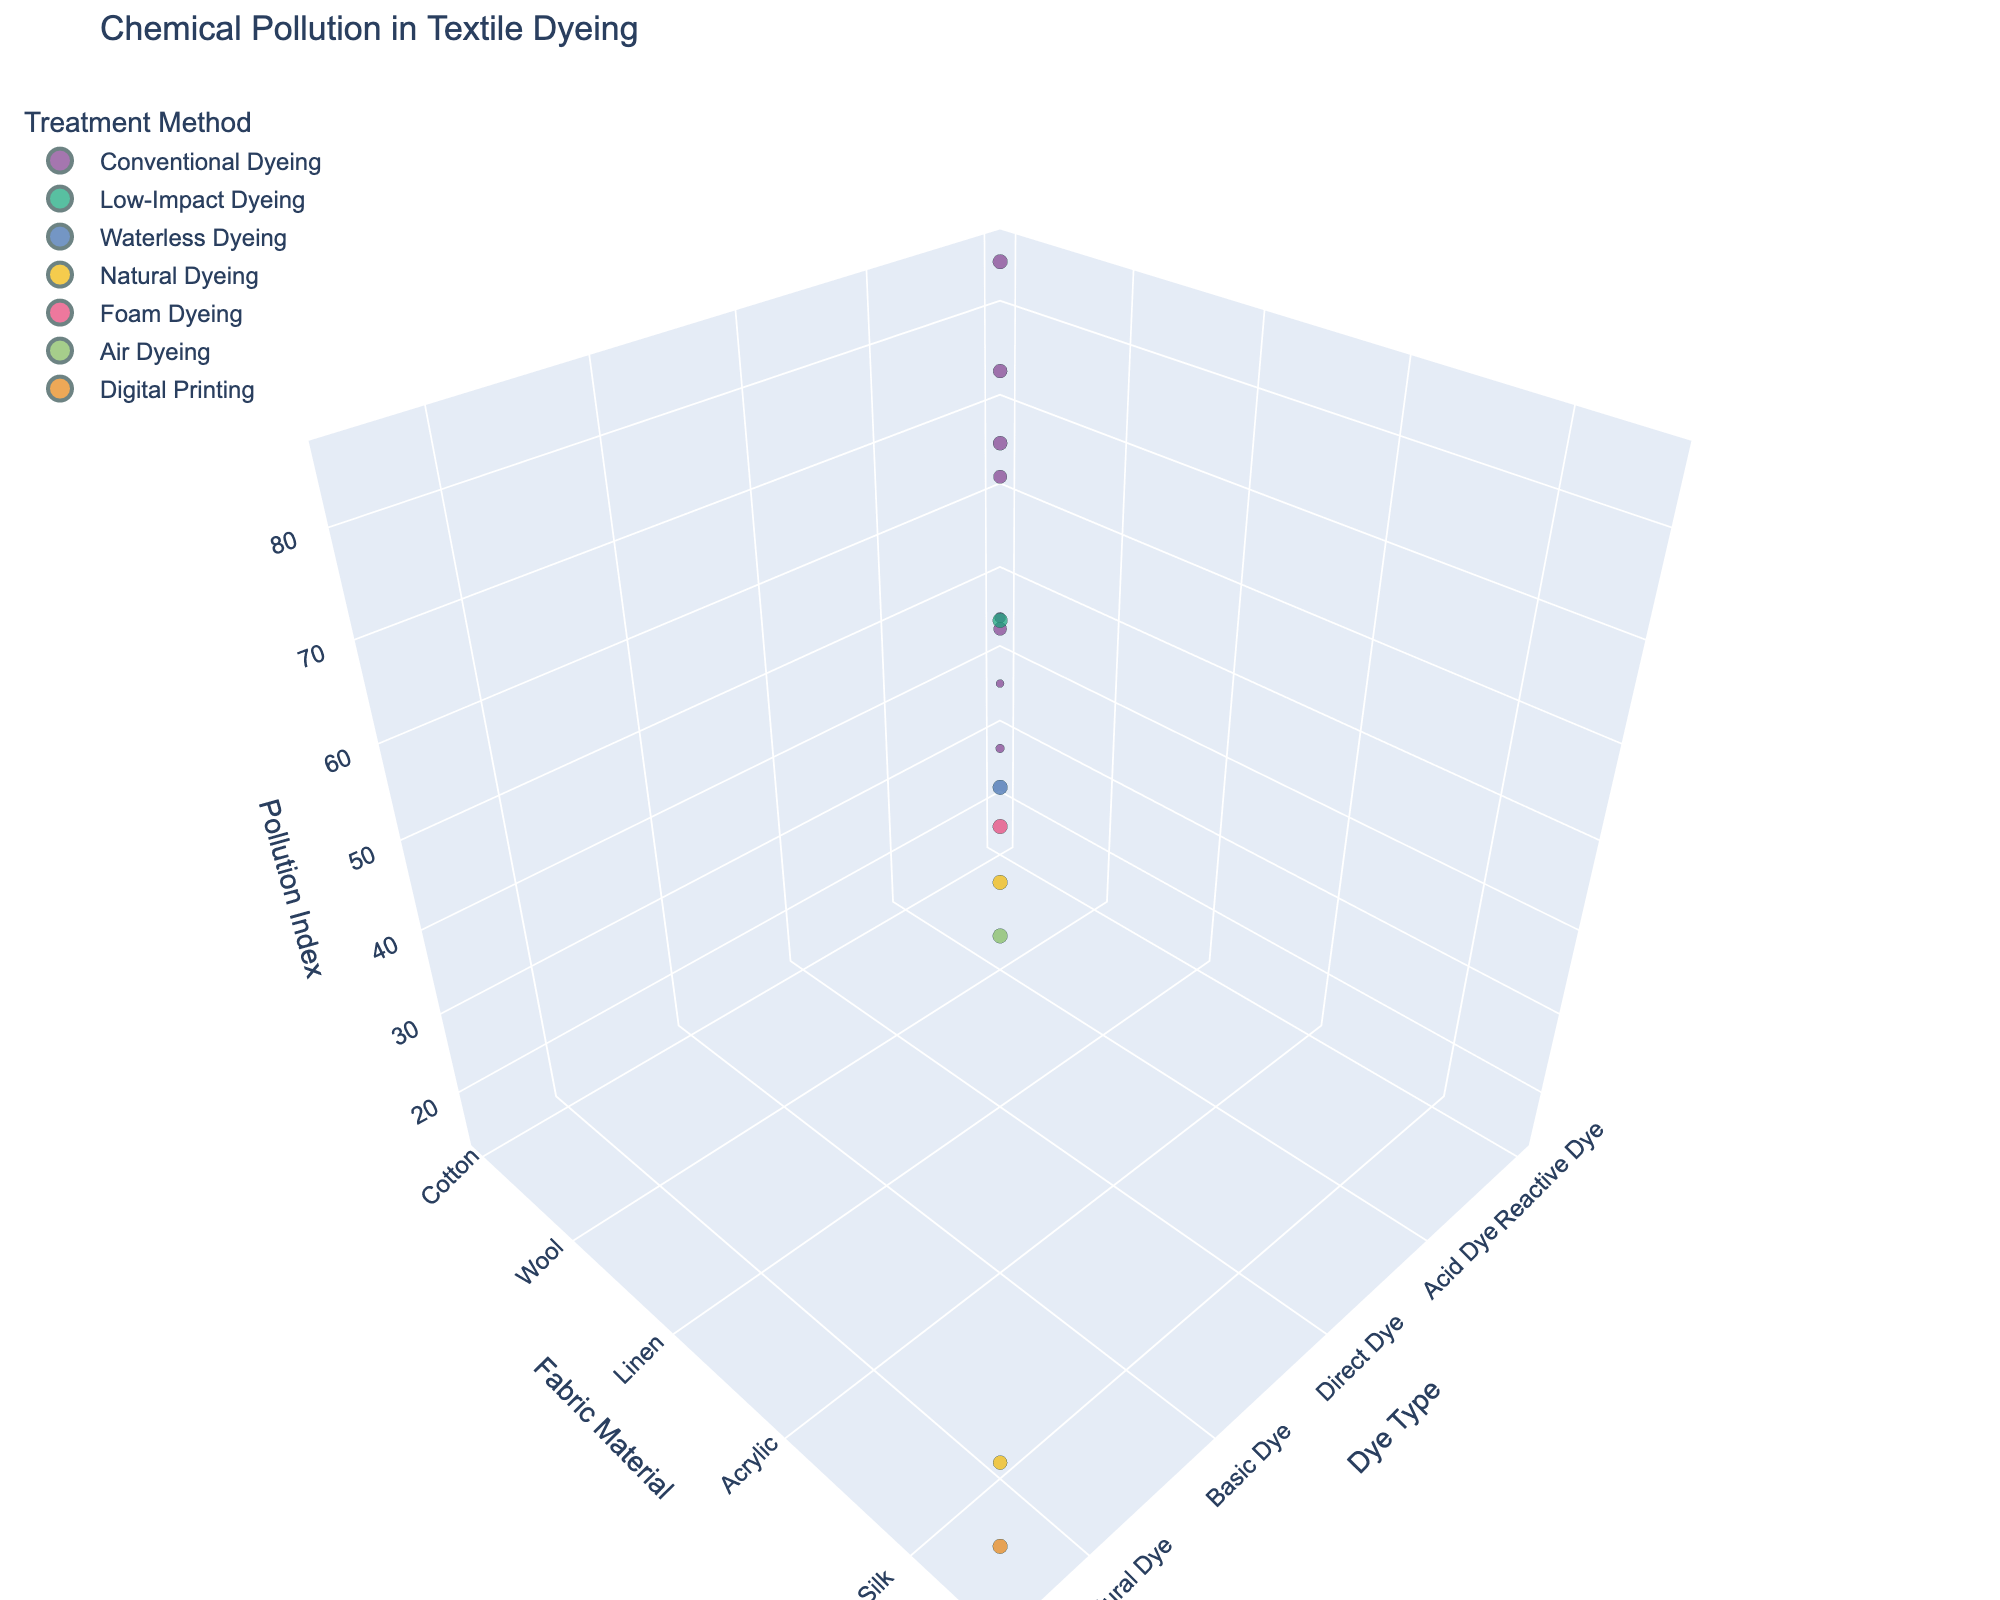What's the title of the 3D plot? The title of the plot is usually visible at the top of the figure.
Answer: Chemical Pollution in Textile Dyeing How many data points represent Conventional Dyeing? Count the number of data points that are colored the same and labeled as "Conventional Dyeing".
Answer: 7 Which dye type has the lowest chemical pollution index and what is the treatment method used? Look for the data point with the smallest z-value and note its x (Dye Type) and color (Treatment Method).
Answer: Natural Dye, Natural Dyeing What is the chemical pollution index for Reactive Dye with Conventional Dyeing on Cotton? Find the data point where the x-axis is "Reactive Dye", the y-axis is "Cotton", and the color matches "Conventional Dyeing", then read the z-value.
Answer: 85 Which fabric material shows more variety in treatment methods and how many are there? Identify the fabric material with the most distinct colors representing different treatment methods. Count the number of distinct treatment methods for that material.
Answer: Wool, 2 Which combination of fabric material and treatment method has the lowest pollution index? Look for the lowest z-value, then identify the corresponding fabric material and treatment method.
Answer: Silk, Natural Dyeing Compare the chemical pollution index for Disperse Dye on Polyester using Conventional Dyeing and Waterless Dyeing. Which one has a lower index? Find the data points for Disperse Dye on Polyester with both treatment methods and compare their z-values.
Answer: Waterless Dyeing Which dye type and treatment method combination produces the highest pollution index? Look for the highest z-value and identify the corresponding dye type and treatment method.
Answer: Reactive Dye, Conventional Dyeing 